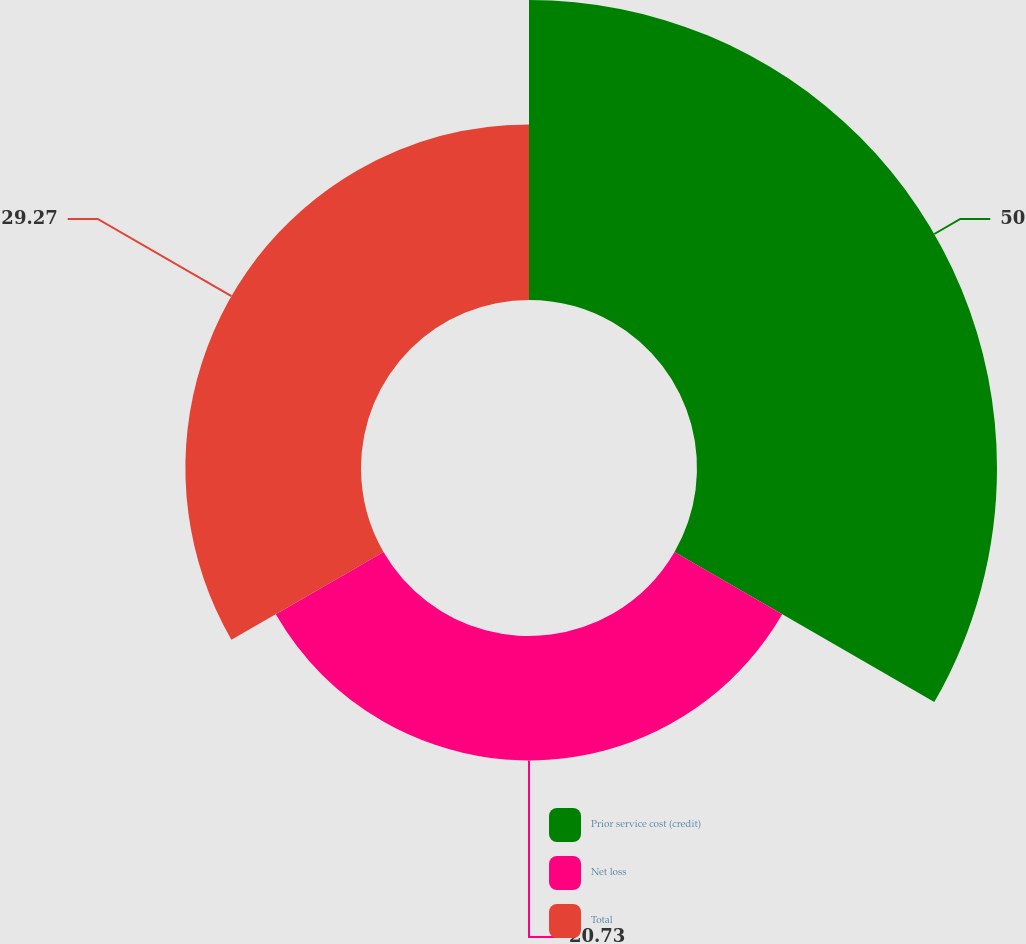Convert chart to OTSL. <chart><loc_0><loc_0><loc_500><loc_500><pie_chart><fcel>Prior service cost (credit)<fcel>Net loss<fcel>Total<nl><fcel>50.0%<fcel>20.73%<fcel>29.27%<nl></chart> 